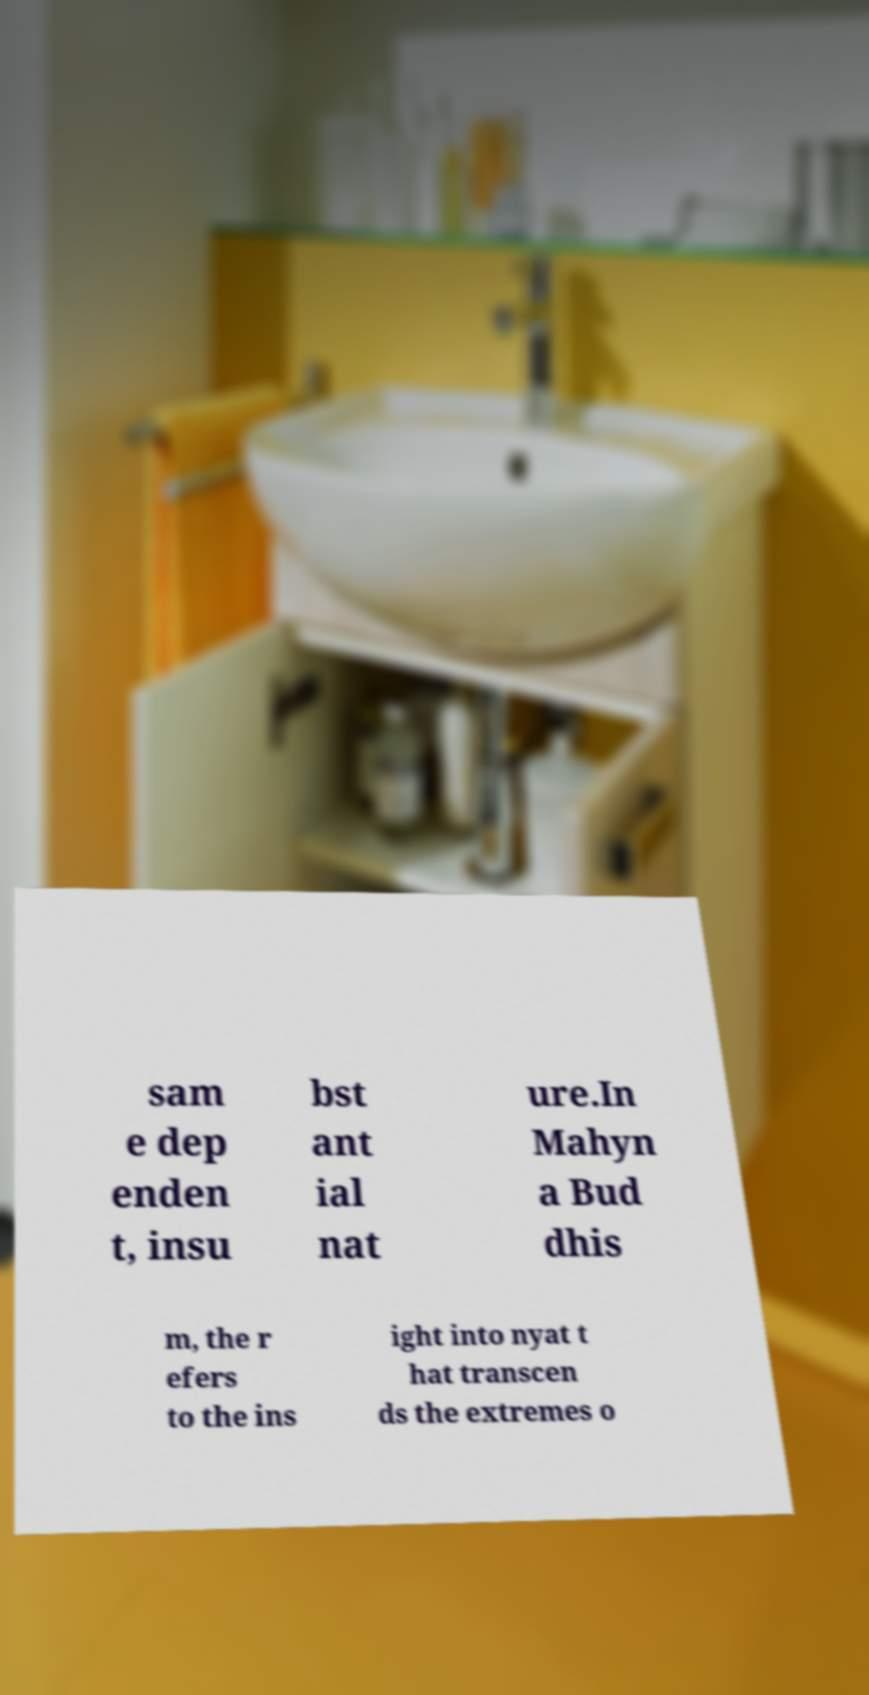Can you read and provide the text displayed in the image?This photo seems to have some interesting text. Can you extract and type it out for me? sam e dep enden t, insu bst ant ial nat ure.In Mahyn a Bud dhis m, the r efers to the ins ight into nyat t hat transcen ds the extremes o 